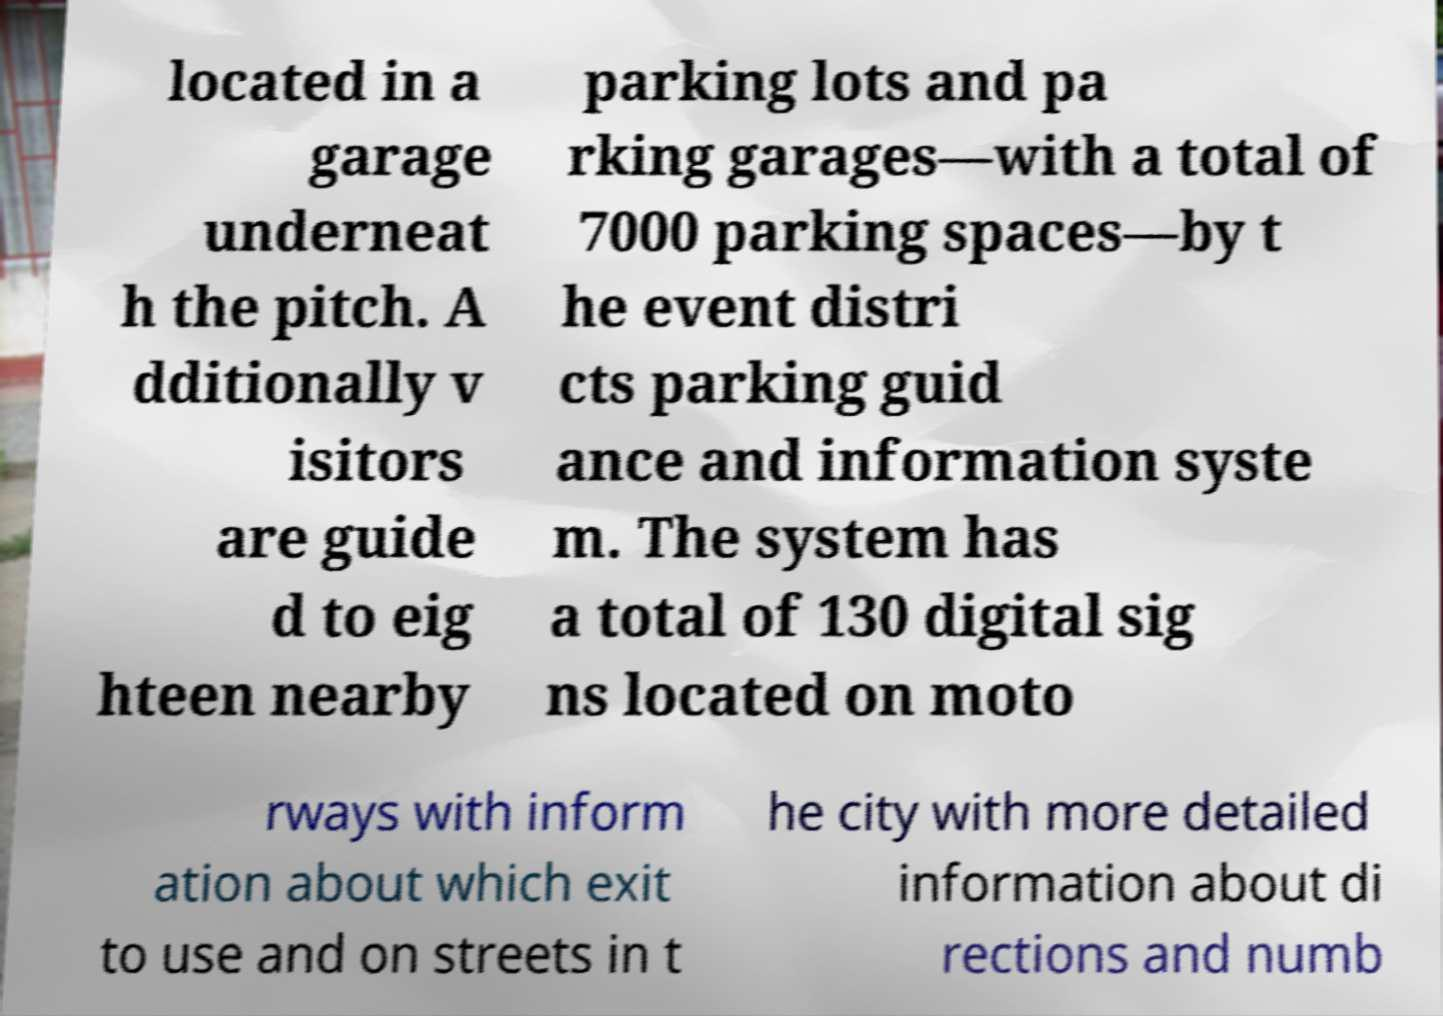What could be the purpose of this informational sign? This informational sign aims to guide visitors to available parking spaces during events. It directs them to a specific garage and provides details about additional parking options, ensuring that the attendees can find parking efficiently and enhance their event experience. 